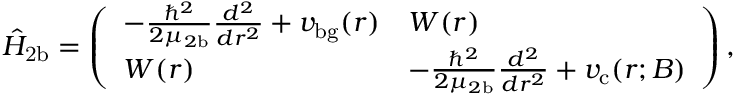Convert formula to latex. <formula><loc_0><loc_0><loc_500><loc_500>\hat { H } _ { 2 b } = \left ( \begin{array} { l l } { - \frac { \hbar { ^ } { 2 } } { 2 \mu _ { 2 b } } \frac { d ^ { 2 } } { d r ^ { 2 } } + v _ { b g } ( r ) } & { W ( r ) } \\ { W ( r ) } & { - \frac { \hbar { ^ } { 2 } } { 2 \mu _ { 2 b } } \frac { d ^ { 2 } } { d r ^ { 2 } } + v _ { c } ( r ; B ) } \end{array} \right ) ,</formula> 